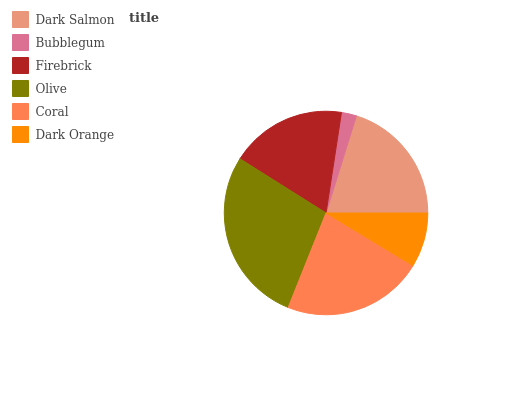Is Bubblegum the minimum?
Answer yes or no. Yes. Is Olive the maximum?
Answer yes or no. Yes. Is Firebrick the minimum?
Answer yes or no. No. Is Firebrick the maximum?
Answer yes or no. No. Is Firebrick greater than Bubblegum?
Answer yes or no. Yes. Is Bubblegum less than Firebrick?
Answer yes or no. Yes. Is Bubblegum greater than Firebrick?
Answer yes or no. No. Is Firebrick less than Bubblegum?
Answer yes or no. No. Is Dark Salmon the high median?
Answer yes or no. Yes. Is Firebrick the low median?
Answer yes or no. Yes. Is Firebrick the high median?
Answer yes or no. No. Is Coral the low median?
Answer yes or no. No. 